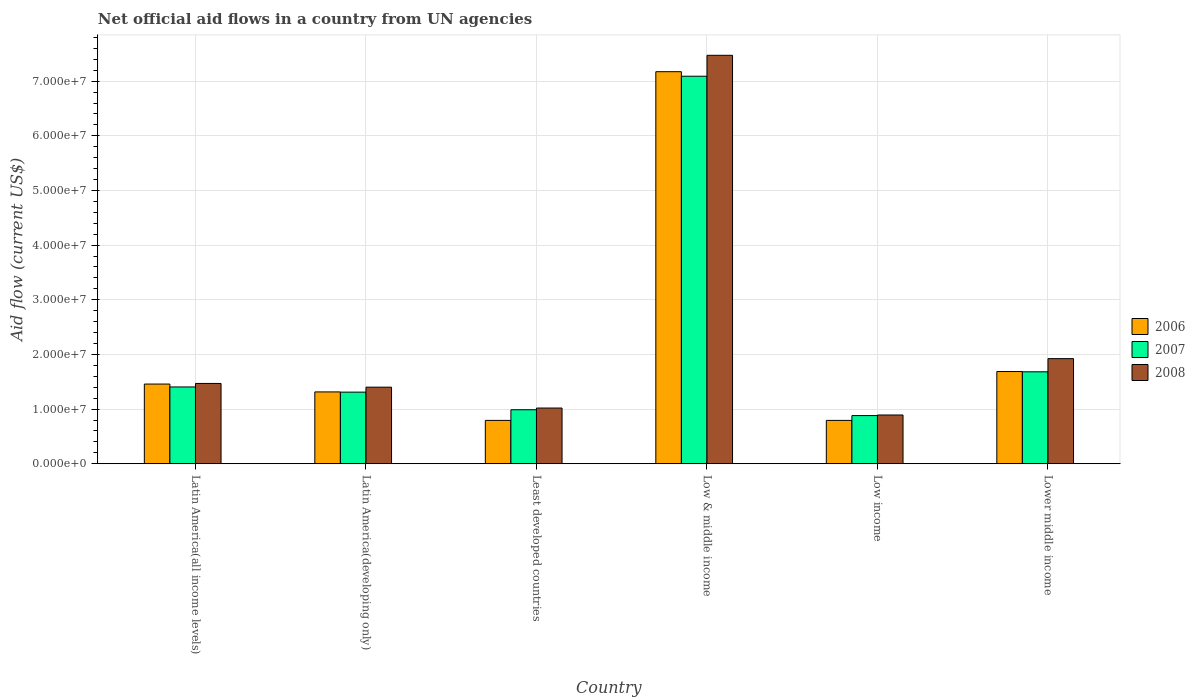How many different coloured bars are there?
Offer a very short reply. 3. How many groups of bars are there?
Give a very brief answer. 6. How many bars are there on the 1st tick from the right?
Make the answer very short. 3. What is the label of the 2nd group of bars from the left?
Provide a short and direct response. Latin America(developing only). In how many cases, is the number of bars for a given country not equal to the number of legend labels?
Keep it short and to the point. 0. What is the net official aid flow in 2008 in Low income?
Offer a terse response. 8.92e+06. Across all countries, what is the maximum net official aid flow in 2007?
Provide a short and direct response. 7.09e+07. Across all countries, what is the minimum net official aid flow in 2007?
Provide a short and direct response. 8.81e+06. In which country was the net official aid flow in 2006 maximum?
Your response must be concise. Low & middle income. What is the total net official aid flow in 2008 in the graph?
Offer a terse response. 1.42e+08. What is the difference between the net official aid flow in 2008 in Low & middle income and that in Lower middle income?
Provide a short and direct response. 5.55e+07. What is the difference between the net official aid flow in 2007 in Latin America(all income levels) and the net official aid flow in 2008 in Low income?
Keep it short and to the point. 5.13e+06. What is the average net official aid flow in 2006 per country?
Your answer should be very brief. 2.20e+07. What is the difference between the net official aid flow of/in 2008 and net official aid flow of/in 2006 in Latin America(all income levels)?
Offer a very short reply. 1.10e+05. What is the ratio of the net official aid flow in 2006 in Low income to that in Lower middle income?
Provide a short and direct response. 0.47. Is the net official aid flow in 2007 in Latin America(all income levels) less than that in Low income?
Your answer should be very brief. No. What is the difference between the highest and the second highest net official aid flow in 2007?
Your response must be concise. 5.41e+07. What is the difference between the highest and the lowest net official aid flow in 2008?
Provide a succinct answer. 6.58e+07. In how many countries, is the net official aid flow in 2008 greater than the average net official aid flow in 2008 taken over all countries?
Your answer should be compact. 1. What does the 1st bar from the left in Latin America(all income levels) represents?
Provide a short and direct response. 2006. What does the 3rd bar from the right in Lower middle income represents?
Your response must be concise. 2006. Is it the case that in every country, the sum of the net official aid flow in 2006 and net official aid flow in 2008 is greater than the net official aid flow in 2007?
Ensure brevity in your answer.  Yes. How many bars are there?
Your response must be concise. 18. Does the graph contain any zero values?
Keep it short and to the point. No. Does the graph contain grids?
Your answer should be very brief. Yes. How many legend labels are there?
Ensure brevity in your answer.  3. What is the title of the graph?
Give a very brief answer. Net official aid flows in a country from UN agencies. What is the label or title of the Y-axis?
Ensure brevity in your answer.  Aid flow (current US$). What is the Aid flow (current US$) of 2006 in Latin America(all income levels)?
Make the answer very short. 1.46e+07. What is the Aid flow (current US$) in 2007 in Latin America(all income levels)?
Offer a very short reply. 1.40e+07. What is the Aid flow (current US$) in 2008 in Latin America(all income levels)?
Provide a succinct answer. 1.47e+07. What is the Aid flow (current US$) in 2006 in Latin America(developing only)?
Your answer should be very brief. 1.31e+07. What is the Aid flow (current US$) in 2007 in Latin America(developing only)?
Offer a terse response. 1.31e+07. What is the Aid flow (current US$) in 2008 in Latin America(developing only)?
Give a very brief answer. 1.40e+07. What is the Aid flow (current US$) of 2006 in Least developed countries?
Your response must be concise. 7.93e+06. What is the Aid flow (current US$) in 2007 in Least developed countries?
Your answer should be very brief. 9.88e+06. What is the Aid flow (current US$) of 2008 in Least developed countries?
Make the answer very short. 1.02e+07. What is the Aid flow (current US$) of 2006 in Low & middle income?
Ensure brevity in your answer.  7.17e+07. What is the Aid flow (current US$) in 2007 in Low & middle income?
Offer a terse response. 7.09e+07. What is the Aid flow (current US$) in 2008 in Low & middle income?
Your answer should be compact. 7.47e+07. What is the Aid flow (current US$) of 2006 in Low income?
Offer a very short reply. 7.93e+06. What is the Aid flow (current US$) in 2007 in Low income?
Ensure brevity in your answer.  8.81e+06. What is the Aid flow (current US$) in 2008 in Low income?
Make the answer very short. 8.92e+06. What is the Aid flow (current US$) in 2006 in Lower middle income?
Provide a short and direct response. 1.69e+07. What is the Aid flow (current US$) of 2007 in Lower middle income?
Provide a succinct answer. 1.68e+07. What is the Aid flow (current US$) of 2008 in Lower middle income?
Offer a terse response. 1.92e+07. Across all countries, what is the maximum Aid flow (current US$) of 2006?
Your response must be concise. 7.17e+07. Across all countries, what is the maximum Aid flow (current US$) in 2007?
Your response must be concise. 7.09e+07. Across all countries, what is the maximum Aid flow (current US$) of 2008?
Give a very brief answer. 7.47e+07. Across all countries, what is the minimum Aid flow (current US$) of 2006?
Give a very brief answer. 7.93e+06. Across all countries, what is the minimum Aid flow (current US$) in 2007?
Make the answer very short. 8.81e+06. Across all countries, what is the minimum Aid flow (current US$) in 2008?
Give a very brief answer. 8.92e+06. What is the total Aid flow (current US$) in 2006 in the graph?
Offer a very short reply. 1.32e+08. What is the total Aid flow (current US$) in 2007 in the graph?
Your answer should be compact. 1.34e+08. What is the total Aid flow (current US$) in 2008 in the graph?
Your answer should be compact. 1.42e+08. What is the difference between the Aid flow (current US$) of 2006 in Latin America(all income levels) and that in Latin America(developing only)?
Keep it short and to the point. 1.44e+06. What is the difference between the Aid flow (current US$) in 2007 in Latin America(all income levels) and that in Latin America(developing only)?
Provide a succinct answer. 9.50e+05. What is the difference between the Aid flow (current US$) of 2008 in Latin America(all income levels) and that in Latin America(developing only)?
Ensure brevity in your answer.  6.80e+05. What is the difference between the Aid flow (current US$) in 2006 in Latin America(all income levels) and that in Least developed countries?
Ensure brevity in your answer.  6.65e+06. What is the difference between the Aid flow (current US$) of 2007 in Latin America(all income levels) and that in Least developed countries?
Ensure brevity in your answer.  4.17e+06. What is the difference between the Aid flow (current US$) in 2008 in Latin America(all income levels) and that in Least developed countries?
Offer a terse response. 4.50e+06. What is the difference between the Aid flow (current US$) in 2006 in Latin America(all income levels) and that in Low & middle income?
Your answer should be compact. -5.72e+07. What is the difference between the Aid flow (current US$) in 2007 in Latin America(all income levels) and that in Low & middle income?
Provide a short and direct response. -5.68e+07. What is the difference between the Aid flow (current US$) in 2008 in Latin America(all income levels) and that in Low & middle income?
Ensure brevity in your answer.  -6.00e+07. What is the difference between the Aid flow (current US$) in 2006 in Latin America(all income levels) and that in Low income?
Offer a terse response. 6.65e+06. What is the difference between the Aid flow (current US$) in 2007 in Latin America(all income levels) and that in Low income?
Provide a succinct answer. 5.24e+06. What is the difference between the Aid flow (current US$) of 2008 in Latin America(all income levels) and that in Low income?
Offer a very short reply. 5.77e+06. What is the difference between the Aid flow (current US$) in 2006 in Latin America(all income levels) and that in Lower middle income?
Give a very brief answer. -2.29e+06. What is the difference between the Aid flow (current US$) of 2007 in Latin America(all income levels) and that in Lower middle income?
Provide a succinct answer. -2.77e+06. What is the difference between the Aid flow (current US$) in 2008 in Latin America(all income levels) and that in Lower middle income?
Give a very brief answer. -4.54e+06. What is the difference between the Aid flow (current US$) of 2006 in Latin America(developing only) and that in Least developed countries?
Your answer should be compact. 5.21e+06. What is the difference between the Aid flow (current US$) in 2007 in Latin America(developing only) and that in Least developed countries?
Ensure brevity in your answer.  3.22e+06. What is the difference between the Aid flow (current US$) in 2008 in Latin America(developing only) and that in Least developed countries?
Keep it short and to the point. 3.82e+06. What is the difference between the Aid flow (current US$) in 2006 in Latin America(developing only) and that in Low & middle income?
Keep it short and to the point. -5.86e+07. What is the difference between the Aid flow (current US$) of 2007 in Latin America(developing only) and that in Low & middle income?
Your answer should be compact. -5.78e+07. What is the difference between the Aid flow (current US$) of 2008 in Latin America(developing only) and that in Low & middle income?
Offer a terse response. -6.07e+07. What is the difference between the Aid flow (current US$) of 2006 in Latin America(developing only) and that in Low income?
Your answer should be compact. 5.21e+06. What is the difference between the Aid flow (current US$) of 2007 in Latin America(developing only) and that in Low income?
Make the answer very short. 4.29e+06. What is the difference between the Aid flow (current US$) of 2008 in Latin America(developing only) and that in Low income?
Offer a very short reply. 5.09e+06. What is the difference between the Aid flow (current US$) of 2006 in Latin America(developing only) and that in Lower middle income?
Ensure brevity in your answer.  -3.73e+06. What is the difference between the Aid flow (current US$) in 2007 in Latin America(developing only) and that in Lower middle income?
Provide a succinct answer. -3.72e+06. What is the difference between the Aid flow (current US$) in 2008 in Latin America(developing only) and that in Lower middle income?
Ensure brevity in your answer.  -5.22e+06. What is the difference between the Aid flow (current US$) of 2006 in Least developed countries and that in Low & middle income?
Make the answer very short. -6.38e+07. What is the difference between the Aid flow (current US$) in 2007 in Least developed countries and that in Low & middle income?
Your response must be concise. -6.10e+07. What is the difference between the Aid flow (current US$) in 2008 in Least developed countries and that in Low & middle income?
Keep it short and to the point. -6.45e+07. What is the difference between the Aid flow (current US$) in 2006 in Least developed countries and that in Low income?
Offer a terse response. 0. What is the difference between the Aid flow (current US$) of 2007 in Least developed countries and that in Low income?
Make the answer very short. 1.07e+06. What is the difference between the Aid flow (current US$) in 2008 in Least developed countries and that in Low income?
Keep it short and to the point. 1.27e+06. What is the difference between the Aid flow (current US$) in 2006 in Least developed countries and that in Lower middle income?
Provide a short and direct response. -8.94e+06. What is the difference between the Aid flow (current US$) in 2007 in Least developed countries and that in Lower middle income?
Offer a terse response. -6.94e+06. What is the difference between the Aid flow (current US$) in 2008 in Least developed countries and that in Lower middle income?
Provide a short and direct response. -9.04e+06. What is the difference between the Aid flow (current US$) in 2006 in Low & middle income and that in Low income?
Your answer should be very brief. 6.38e+07. What is the difference between the Aid flow (current US$) of 2007 in Low & middle income and that in Low income?
Your answer should be compact. 6.21e+07. What is the difference between the Aid flow (current US$) in 2008 in Low & middle income and that in Low income?
Make the answer very short. 6.58e+07. What is the difference between the Aid flow (current US$) in 2006 in Low & middle income and that in Lower middle income?
Keep it short and to the point. 5.49e+07. What is the difference between the Aid flow (current US$) in 2007 in Low & middle income and that in Lower middle income?
Provide a succinct answer. 5.41e+07. What is the difference between the Aid flow (current US$) in 2008 in Low & middle income and that in Lower middle income?
Provide a short and direct response. 5.55e+07. What is the difference between the Aid flow (current US$) of 2006 in Low income and that in Lower middle income?
Offer a terse response. -8.94e+06. What is the difference between the Aid flow (current US$) in 2007 in Low income and that in Lower middle income?
Offer a very short reply. -8.01e+06. What is the difference between the Aid flow (current US$) in 2008 in Low income and that in Lower middle income?
Keep it short and to the point. -1.03e+07. What is the difference between the Aid flow (current US$) of 2006 in Latin America(all income levels) and the Aid flow (current US$) of 2007 in Latin America(developing only)?
Provide a short and direct response. 1.48e+06. What is the difference between the Aid flow (current US$) of 2006 in Latin America(all income levels) and the Aid flow (current US$) of 2008 in Latin America(developing only)?
Your answer should be compact. 5.70e+05. What is the difference between the Aid flow (current US$) in 2006 in Latin America(all income levels) and the Aid flow (current US$) in 2007 in Least developed countries?
Keep it short and to the point. 4.70e+06. What is the difference between the Aid flow (current US$) of 2006 in Latin America(all income levels) and the Aid flow (current US$) of 2008 in Least developed countries?
Give a very brief answer. 4.39e+06. What is the difference between the Aid flow (current US$) in 2007 in Latin America(all income levels) and the Aid flow (current US$) in 2008 in Least developed countries?
Give a very brief answer. 3.86e+06. What is the difference between the Aid flow (current US$) of 2006 in Latin America(all income levels) and the Aid flow (current US$) of 2007 in Low & middle income?
Offer a very short reply. -5.63e+07. What is the difference between the Aid flow (current US$) in 2006 in Latin America(all income levels) and the Aid flow (current US$) in 2008 in Low & middle income?
Provide a short and direct response. -6.02e+07. What is the difference between the Aid flow (current US$) in 2007 in Latin America(all income levels) and the Aid flow (current US$) in 2008 in Low & middle income?
Offer a very short reply. -6.07e+07. What is the difference between the Aid flow (current US$) of 2006 in Latin America(all income levels) and the Aid flow (current US$) of 2007 in Low income?
Keep it short and to the point. 5.77e+06. What is the difference between the Aid flow (current US$) of 2006 in Latin America(all income levels) and the Aid flow (current US$) of 2008 in Low income?
Give a very brief answer. 5.66e+06. What is the difference between the Aid flow (current US$) in 2007 in Latin America(all income levels) and the Aid flow (current US$) in 2008 in Low income?
Give a very brief answer. 5.13e+06. What is the difference between the Aid flow (current US$) of 2006 in Latin America(all income levels) and the Aid flow (current US$) of 2007 in Lower middle income?
Provide a succinct answer. -2.24e+06. What is the difference between the Aid flow (current US$) in 2006 in Latin America(all income levels) and the Aid flow (current US$) in 2008 in Lower middle income?
Offer a terse response. -4.65e+06. What is the difference between the Aid flow (current US$) in 2007 in Latin America(all income levels) and the Aid flow (current US$) in 2008 in Lower middle income?
Your response must be concise. -5.18e+06. What is the difference between the Aid flow (current US$) of 2006 in Latin America(developing only) and the Aid flow (current US$) of 2007 in Least developed countries?
Provide a short and direct response. 3.26e+06. What is the difference between the Aid flow (current US$) in 2006 in Latin America(developing only) and the Aid flow (current US$) in 2008 in Least developed countries?
Provide a succinct answer. 2.95e+06. What is the difference between the Aid flow (current US$) in 2007 in Latin America(developing only) and the Aid flow (current US$) in 2008 in Least developed countries?
Make the answer very short. 2.91e+06. What is the difference between the Aid flow (current US$) in 2006 in Latin America(developing only) and the Aid flow (current US$) in 2007 in Low & middle income?
Ensure brevity in your answer.  -5.78e+07. What is the difference between the Aid flow (current US$) of 2006 in Latin America(developing only) and the Aid flow (current US$) of 2008 in Low & middle income?
Your answer should be compact. -6.16e+07. What is the difference between the Aid flow (current US$) of 2007 in Latin America(developing only) and the Aid flow (current US$) of 2008 in Low & middle income?
Provide a short and direct response. -6.16e+07. What is the difference between the Aid flow (current US$) in 2006 in Latin America(developing only) and the Aid flow (current US$) in 2007 in Low income?
Your response must be concise. 4.33e+06. What is the difference between the Aid flow (current US$) of 2006 in Latin America(developing only) and the Aid flow (current US$) of 2008 in Low income?
Provide a succinct answer. 4.22e+06. What is the difference between the Aid flow (current US$) in 2007 in Latin America(developing only) and the Aid flow (current US$) in 2008 in Low income?
Keep it short and to the point. 4.18e+06. What is the difference between the Aid flow (current US$) in 2006 in Latin America(developing only) and the Aid flow (current US$) in 2007 in Lower middle income?
Keep it short and to the point. -3.68e+06. What is the difference between the Aid flow (current US$) of 2006 in Latin America(developing only) and the Aid flow (current US$) of 2008 in Lower middle income?
Ensure brevity in your answer.  -6.09e+06. What is the difference between the Aid flow (current US$) in 2007 in Latin America(developing only) and the Aid flow (current US$) in 2008 in Lower middle income?
Make the answer very short. -6.13e+06. What is the difference between the Aid flow (current US$) of 2006 in Least developed countries and the Aid flow (current US$) of 2007 in Low & middle income?
Make the answer very short. -6.30e+07. What is the difference between the Aid flow (current US$) in 2006 in Least developed countries and the Aid flow (current US$) in 2008 in Low & middle income?
Give a very brief answer. -6.68e+07. What is the difference between the Aid flow (current US$) in 2007 in Least developed countries and the Aid flow (current US$) in 2008 in Low & middle income?
Ensure brevity in your answer.  -6.48e+07. What is the difference between the Aid flow (current US$) of 2006 in Least developed countries and the Aid flow (current US$) of 2007 in Low income?
Your answer should be very brief. -8.80e+05. What is the difference between the Aid flow (current US$) of 2006 in Least developed countries and the Aid flow (current US$) of 2008 in Low income?
Your answer should be very brief. -9.90e+05. What is the difference between the Aid flow (current US$) of 2007 in Least developed countries and the Aid flow (current US$) of 2008 in Low income?
Keep it short and to the point. 9.60e+05. What is the difference between the Aid flow (current US$) of 2006 in Least developed countries and the Aid flow (current US$) of 2007 in Lower middle income?
Provide a succinct answer. -8.89e+06. What is the difference between the Aid flow (current US$) of 2006 in Least developed countries and the Aid flow (current US$) of 2008 in Lower middle income?
Your answer should be very brief. -1.13e+07. What is the difference between the Aid flow (current US$) in 2007 in Least developed countries and the Aid flow (current US$) in 2008 in Lower middle income?
Offer a terse response. -9.35e+06. What is the difference between the Aid flow (current US$) in 2006 in Low & middle income and the Aid flow (current US$) in 2007 in Low income?
Ensure brevity in your answer.  6.29e+07. What is the difference between the Aid flow (current US$) in 2006 in Low & middle income and the Aid flow (current US$) in 2008 in Low income?
Ensure brevity in your answer.  6.28e+07. What is the difference between the Aid flow (current US$) in 2007 in Low & middle income and the Aid flow (current US$) in 2008 in Low income?
Your response must be concise. 6.20e+07. What is the difference between the Aid flow (current US$) of 2006 in Low & middle income and the Aid flow (current US$) of 2007 in Lower middle income?
Offer a terse response. 5.49e+07. What is the difference between the Aid flow (current US$) in 2006 in Low & middle income and the Aid flow (current US$) in 2008 in Lower middle income?
Your response must be concise. 5.25e+07. What is the difference between the Aid flow (current US$) of 2007 in Low & middle income and the Aid flow (current US$) of 2008 in Lower middle income?
Your answer should be compact. 5.17e+07. What is the difference between the Aid flow (current US$) of 2006 in Low income and the Aid flow (current US$) of 2007 in Lower middle income?
Provide a short and direct response. -8.89e+06. What is the difference between the Aid flow (current US$) in 2006 in Low income and the Aid flow (current US$) in 2008 in Lower middle income?
Ensure brevity in your answer.  -1.13e+07. What is the difference between the Aid flow (current US$) in 2007 in Low income and the Aid flow (current US$) in 2008 in Lower middle income?
Your response must be concise. -1.04e+07. What is the average Aid flow (current US$) in 2006 per country?
Give a very brief answer. 2.20e+07. What is the average Aid flow (current US$) in 2007 per country?
Provide a succinct answer. 2.23e+07. What is the average Aid flow (current US$) of 2008 per country?
Your answer should be compact. 2.36e+07. What is the difference between the Aid flow (current US$) in 2006 and Aid flow (current US$) in 2007 in Latin America(all income levels)?
Provide a succinct answer. 5.30e+05. What is the difference between the Aid flow (current US$) in 2007 and Aid flow (current US$) in 2008 in Latin America(all income levels)?
Your answer should be very brief. -6.40e+05. What is the difference between the Aid flow (current US$) in 2006 and Aid flow (current US$) in 2007 in Latin America(developing only)?
Make the answer very short. 4.00e+04. What is the difference between the Aid flow (current US$) of 2006 and Aid flow (current US$) of 2008 in Latin America(developing only)?
Your answer should be very brief. -8.70e+05. What is the difference between the Aid flow (current US$) in 2007 and Aid flow (current US$) in 2008 in Latin America(developing only)?
Offer a terse response. -9.10e+05. What is the difference between the Aid flow (current US$) of 2006 and Aid flow (current US$) of 2007 in Least developed countries?
Provide a succinct answer. -1.95e+06. What is the difference between the Aid flow (current US$) in 2006 and Aid flow (current US$) in 2008 in Least developed countries?
Give a very brief answer. -2.26e+06. What is the difference between the Aid flow (current US$) of 2007 and Aid flow (current US$) of 2008 in Least developed countries?
Keep it short and to the point. -3.10e+05. What is the difference between the Aid flow (current US$) in 2006 and Aid flow (current US$) in 2007 in Low & middle income?
Provide a short and direct response. 8.30e+05. What is the difference between the Aid flow (current US$) of 2006 and Aid flow (current US$) of 2008 in Low & middle income?
Offer a very short reply. -3.00e+06. What is the difference between the Aid flow (current US$) of 2007 and Aid flow (current US$) of 2008 in Low & middle income?
Your answer should be very brief. -3.83e+06. What is the difference between the Aid flow (current US$) in 2006 and Aid flow (current US$) in 2007 in Low income?
Keep it short and to the point. -8.80e+05. What is the difference between the Aid flow (current US$) in 2006 and Aid flow (current US$) in 2008 in Low income?
Ensure brevity in your answer.  -9.90e+05. What is the difference between the Aid flow (current US$) of 2007 and Aid flow (current US$) of 2008 in Low income?
Provide a succinct answer. -1.10e+05. What is the difference between the Aid flow (current US$) of 2006 and Aid flow (current US$) of 2008 in Lower middle income?
Provide a succinct answer. -2.36e+06. What is the difference between the Aid flow (current US$) of 2007 and Aid flow (current US$) of 2008 in Lower middle income?
Offer a terse response. -2.41e+06. What is the ratio of the Aid flow (current US$) in 2006 in Latin America(all income levels) to that in Latin America(developing only)?
Provide a short and direct response. 1.11. What is the ratio of the Aid flow (current US$) in 2007 in Latin America(all income levels) to that in Latin America(developing only)?
Make the answer very short. 1.07. What is the ratio of the Aid flow (current US$) in 2008 in Latin America(all income levels) to that in Latin America(developing only)?
Your answer should be compact. 1.05. What is the ratio of the Aid flow (current US$) in 2006 in Latin America(all income levels) to that in Least developed countries?
Make the answer very short. 1.84. What is the ratio of the Aid flow (current US$) in 2007 in Latin America(all income levels) to that in Least developed countries?
Offer a very short reply. 1.42. What is the ratio of the Aid flow (current US$) in 2008 in Latin America(all income levels) to that in Least developed countries?
Offer a terse response. 1.44. What is the ratio of the Aid flow (current US$) in 2006 in Latin America(all income levels) to that in Low & middle income?
Your answer should be compact. 0.2. What is the ratio of the Aid flow (current US$) in 2007 in Latin America(all income levels) to that in Low & middle income?
Give a very brief answer. 0.2. What is the ratio of the Aid flow (current US$) in 2008 in Latin America(all income levels) to that in Low & middle income?
Offer a terse response. 0.2. What is the ratio of the Aid flow (current US$) in 2006 in Latin America(all income levels) to that in Low income?
Give a very brief answer. 1.84. What is the ratio of the Aid flow (current US$) of 2007 in Latin America(all income levels) to that in Low income?
Offer a terse response. 1.59. What is the ratio of the Aid flow (current US$) in 2008 in Latin America(all income levels) to that in Low income?
Your response must be concise. 1.65. What is the ratio of the Aid flow (current US$) in 2006 in Latin America(all income levels) to that in Lower middle income?
Ensure brevity in your answer.  0.86. What is the ratio of the Aid flow (current US$) in 2007 in Latin America(all income levels) to that in Lower middle income?
Keep it short and to the point. 0.84. What is the ratio of the Aid flow (current US$) of 2008 in Latin America(all income levels) to that in Lower middle income?
Your answer should be very brief. 0.76. What is the ratio of the Aid flow (current US$) in 2006 in Latin America(developing only) to that in Least developed countries?
Your response must be concise. 1.66. What is the ratio of the Aid flow (current US$) of 2007 in Latin America(developing only) to that in Least developed countries?
Offer a terse response. 1.33. What is the ratio of the Aid flow (current US$) in 2008 in Latin America(developing only) to that in Least developed countries?
Provide a short and direct response. 1.37. What is the ratio of the Aid flow (current US$) of 2006 in Latin America(developing only) to that in Low & middle income?
Keep it short and to the point. 0.18. What is the ratio of the Aid flow (current US$) of 2007 in Latin America(developing only) to that in Low & middle income?
Your answer should be compact. 0.18. What is the ratio of the Aid flow (current US$) of 2008 in Latin America(developing only) to that in Low & middle income?
Your answer should be very brief. 0.19. What is the ratio of the Aid flow (current US$) in 2006 in Latin America(developing only) to that in Low income?
Ensure brevity in your answer.  1.66. What is the ratio of the Aid flow (current US$) of 2007 in Latin America(developing only) to that in Low income?
Provide a short and direct response. 1.49. What is the ratio of the Aid flow (current US$) in 2008 in Latin America(developing only) to that in Low income?
Provide a short and direct response. 1.57. What is the ratio of the Aid flow (current US$) in 2006 in Latin America(developing only) to that in Lower middle income?
Provide a short and direct response. 0.78. What is the ratio of the Aid flow (current US$) of 2007 in Latin America(developing only) to that in Lower middle income?
Your answer should be compact. 0.78. What is the ratio of the Aid flow (current US$) in 2008 in Latin America(developing only) to that in Lower middle income?
Provide a succinct answer. 0.73. What is the ratio of the Aid flow (current US$) of 2006 in Least developed countries to that in Low & middle income?
Offer a very short reply. 0.11. What is the ratio of the Aid flow (current US$) in 2007 in Least developed countries to that in Low & middle income?
Your answer should be very brief. 0.14. What is the ratio of the Aid flow (current US$) of 2008 in Least developed countries to that in Low & middle income?
Offer a terse response. 0.14. What is the ratio of the Aid flow (current US$) in 2006 in Least developed countries to that in Low income?
Provide a succinct answer. 1. What is the ratio of the Aid flow (current US$) in 2007 in Least developed countries to that in Low income?
Offer a terse response. 1.12. What is the ratio of the Aid flow (current US$) of 2008 in Least developed countries to that in Low income?
Provide a short and direct response. 1.14. What is the ratio of the Aid flow (current US$) of 2006 in Least developed countries to that in Lower middle income?
Offer a very short reply. 0.47. What is the ratio of the Aid flow (current US$) in 2007 in Least developed countries to that in Lower middle income?
Make the answer very short. 0.59. What is the ratio of the Aid flow (current US$) in 2008 in Least developed countries to that in Lower middle income?
Make the answer very short. 0.53. What is the ratio of the Aid flow (current US$) of 2006 in Low & middle income to that in Low income?
Offer a terse response. 9.05. What is the ratio of the Aid flow (current US$) in 2007 in Low & middle income to that in Low income?
Give a very brief answer. 8.05. What is the ratio of the Aid flow (current US$) in 2008 in Low & middle income to that in Low income?
Your answer should be very brief. 8.38. What is the ratio of the Aid flow (current US$) of 2006 in Low & middle income to that in Lower middle income?
Your answer should be compact. 4.25. What is the ratio of the Aid flow (current US$) of 2007 in Low & middle income to that in Lower middle income?
Offer a terse response. 4.22. What is the ratio of the Aid flow (current US$) in 2008 in Low & middle income to that in Lower middle income?
Ensure brevity in your answer.  3.89. What is the ratio of the Aid flow (current US$) in 2006 in Low income to that in Lower middle income?
Your response must be concise. 0.47. What is the ratio of the Aid flow (current US$) in 2007 in Low income to that in Lower middle income?
Your response must be concise. 0.52. What is the ratio of the Aid flow (current US$) of 2008 in Low income to that in Lower middle income?
Keep it short and to the point. 0.46. What is the difference between the highest and the second highest Aid flow (current US$) in 2006?
Provide a succinct answer. 5.49e+07. What is the difference between the highest and the second highest Aid flow (current US$) of 2007?
Give a very brief answer. 5.41e+07. What is the difference between the highest and the second highest Aid flow (current US$) of 2008?
Your answer should be compact. 5.55e+07. What is the difference between the highest and the lowest Aid flow (current US$) in 2006?
Your response must be concise. 6.38e+07. What is the difference between the highest and the lowest Aid flow (current US$) in 2007?
Provide a succinct answer. 6.21e+07. What is the difference between the highest and the lowest Aid flow (current US$) of 2008?
Provide a succinct answer. 6.58e+07. 